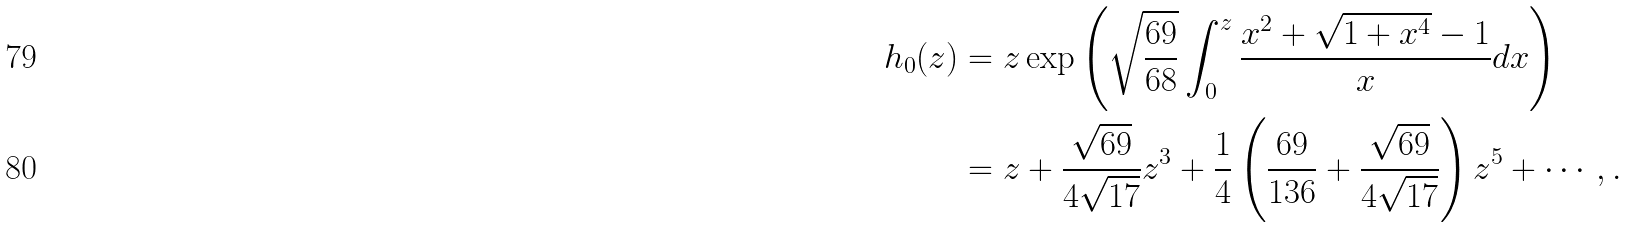Convert formula to latex. <formula><loc_0><loc_0><loc_500><loc_500>h _ { 0 } ( z ) & = z \exp \left ( \sqrt { \frac { 6 9 } { 6 8 } } \int _ { 0 } ^ { z } \frac { x ^ { 2 } + \sqrt { 1 + x ^ { 4 } } - 1 } { x } d x \right ) \\ & = z + \frac { \sqrt { 6 9 } } { 4 \sqrt { 1 7 } } z ^ { 3 } + \frac { 1 } { 4 } \left ( \frac { 6 9 } { 1 3 6 } + \frac { \sqrt { 6 9 } } { 4 \sqrt { 1 7 } } \right ) z ^ { 5 } + \cdots , .</formula> 